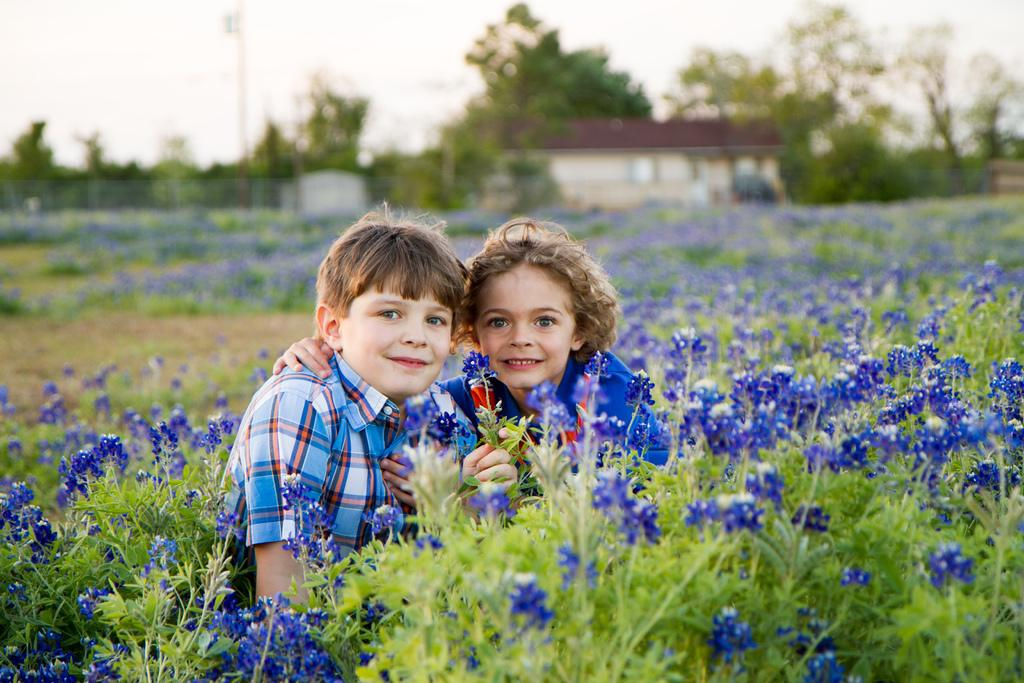What is located at the front of the image? There are plants in the front of the image. What are the kids in the image doing? The kids are smiling in the center of the image. What type of flora can be seen in the image? There are flowers in the image. What can be seen in the background of the image? There are trees, houses, and a pole in the background of the image. Can you hear the bell ringing in the image? There is no bell present in the image, so it cannot be heard. Is there a baseball game happening in the image? There is no indication of a baseball game in the image. 